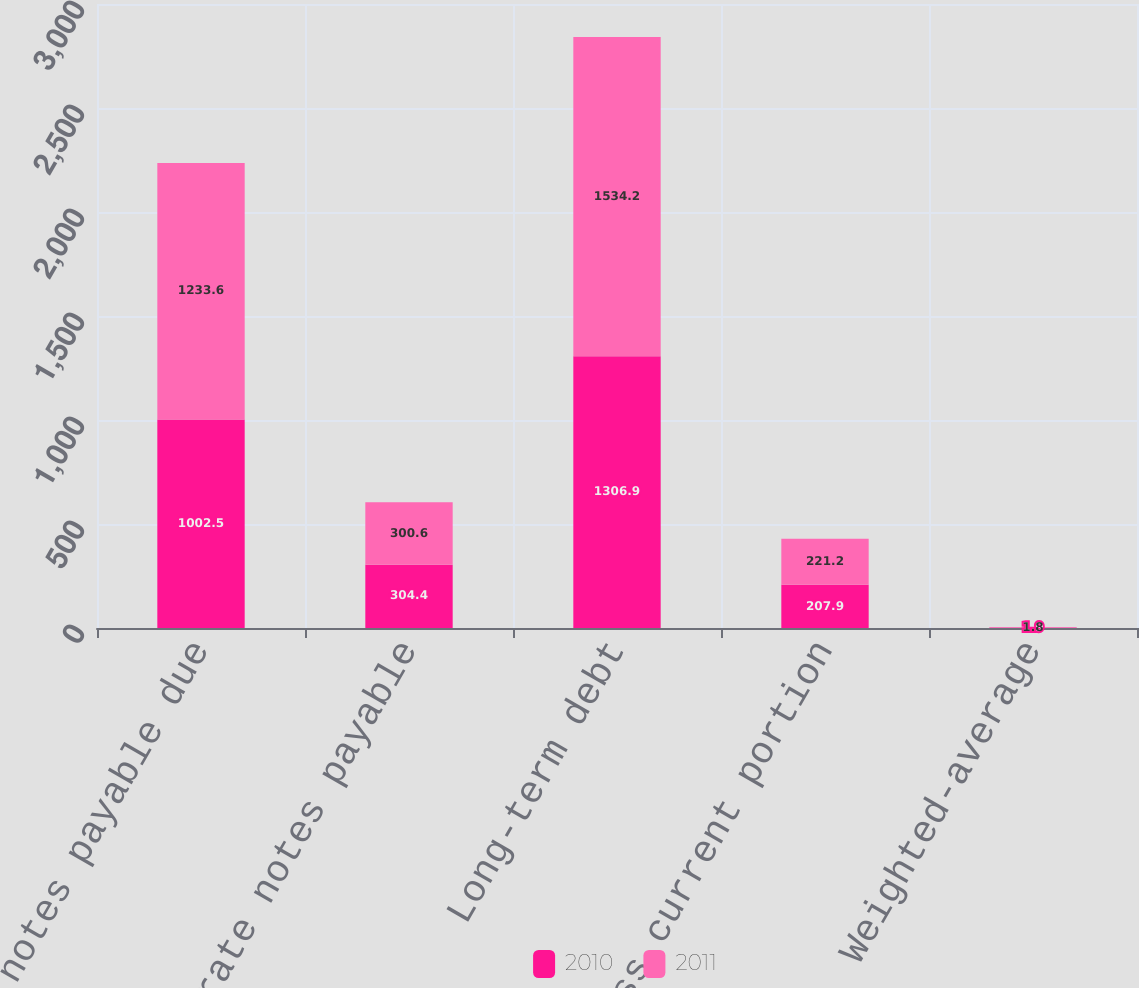Convert chart to OTSL. <chart><loc_0><loc_0><loc_500><loc_500><stacked_bar_chart><ecel><fcel>Fixed-rate notes payable due<fcel>Variable-rate notes payable<fcel>Long-term debt<fcel>Less current portion<fcel>Weighted-average<nl><fcel>2010<fcel>1002.5<fcel>304.4<fcel>1306.9<fcel>207.9<fcel>1.9<nl><fcel>2011<fcel>1233.6<fcel>300.6<fcel>1534.2<fcel>221.2<fcel>1.8<nl></chart> 